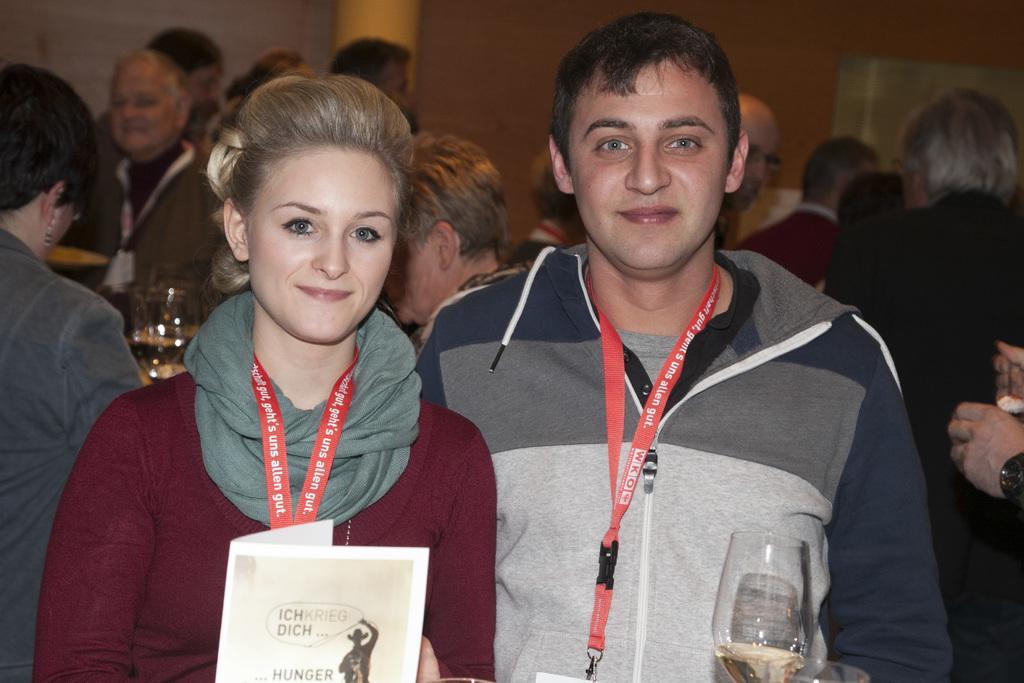Please provide a concise description of this image. As we can see in the image there are woman and man who are standing in front the woman is wearing a scarf around her neck and the man is wearing a jacket and they both are wearing id cards and holding a wine glass and at the back there are people standing and the wall is of brown colour and in between there is a yellow pillar. 